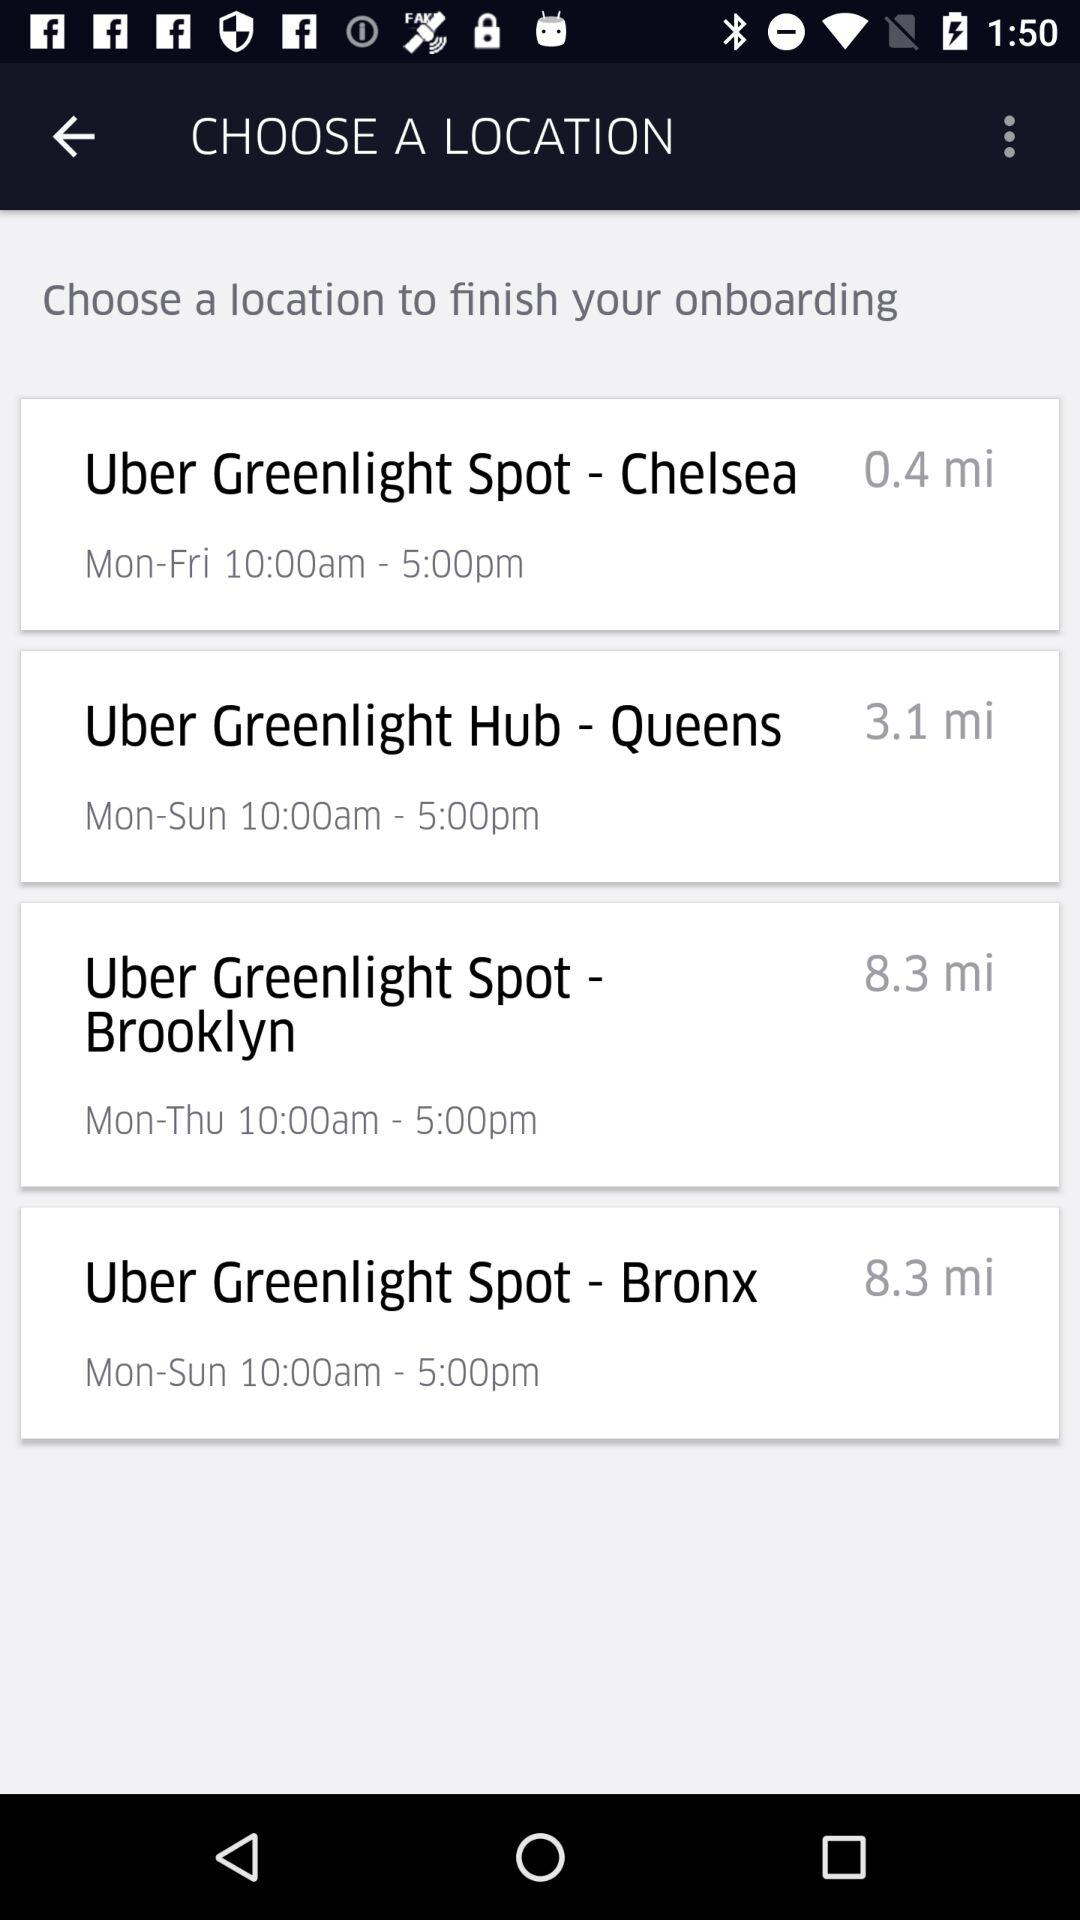8.3 miles is the distance of which location?
When the provided information is insufficient, respond with <no answer>. <no answer> 